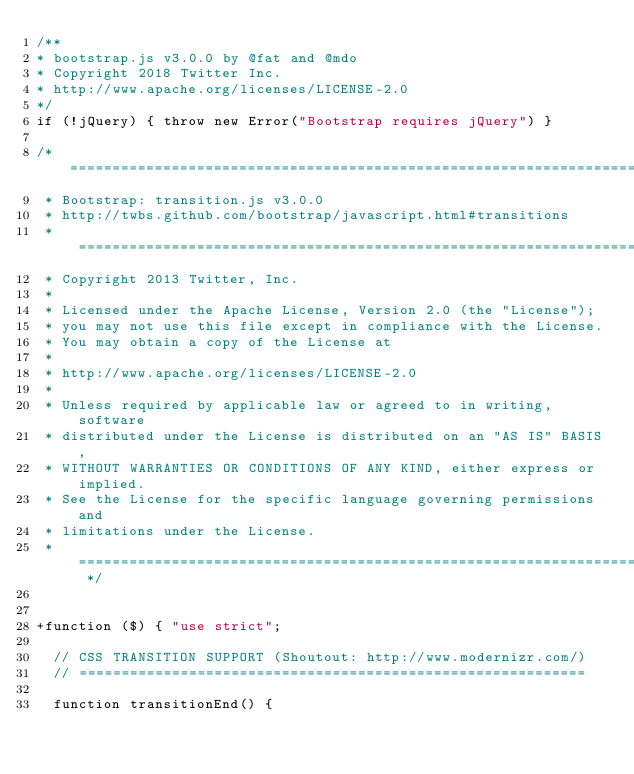Convert code to text. <code><loc_0><loc_0><loc_500><loc_500><_JavaScript_>/**
* bootstrap.js v3.0.0 by @fat and @mdo
* Copyright 2018 Twitter Inc.
* http://www.apache.org/licenses/LICENSE-2.0
*/
if (!jQuery) { throw new Error("Bootstrap requires jQuery") }

/* ========================================================================
 * Bootstrap: transition.js v3.0.0
 * http://twbs.github.com/bootstrap/javascript.html#transitions
 * ========================================================================
 * Copyright 2013 Twitter, Inc.
 *
 * Licensed under the Apache License, Version 2.0 (the "License");
 * you may not use this file except in compliance with the License.
 * You may obtain a copy of the License at
 *
 * http://www.apache.org/licenses/LICENSE-2.0
 *
 * Unless required by applicable law or agreed to in writing, software
 * distributed under the License is distributed on an "AS IS" BASIS,
 * WITHOUT WARRANTIES OR CONDITIONS OF ANY KIND, either express or implied.
 * See the License for the specific language governing permissions and
 * limitations under the License.
 * ======================================================================== */


+function ($) { "use strict";

  // CSS TRANSITION SUPPORT (Shoutout: http://www.modernizr.com/)
  // ============================================================

  function transitionEnd() {</code> 